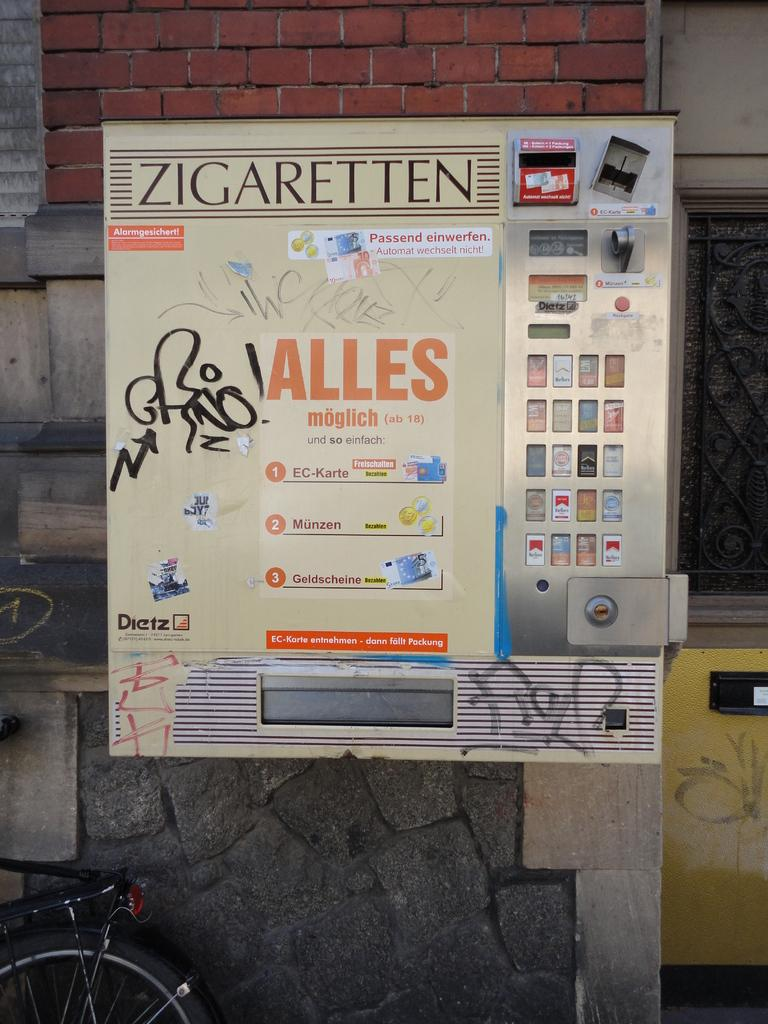<image>
Render a clear and concise summary of the photo. A vending machine reading ALLES on the front. 